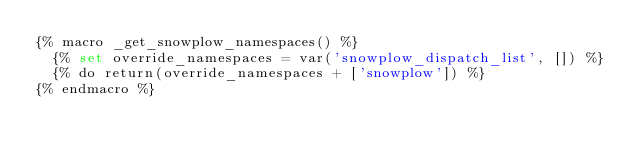Convert code to text. <code><loc_0><loc_0><loc_500><loc_500><_SQL_>{% macro _get_snowplow_namespaces() %}
  {% set override_namespaces = var('snowplow_dispatch_list', []) %}
  {% do return(override_namespaces + ['snowplow']) %}
{% endmacro %}
</code> 